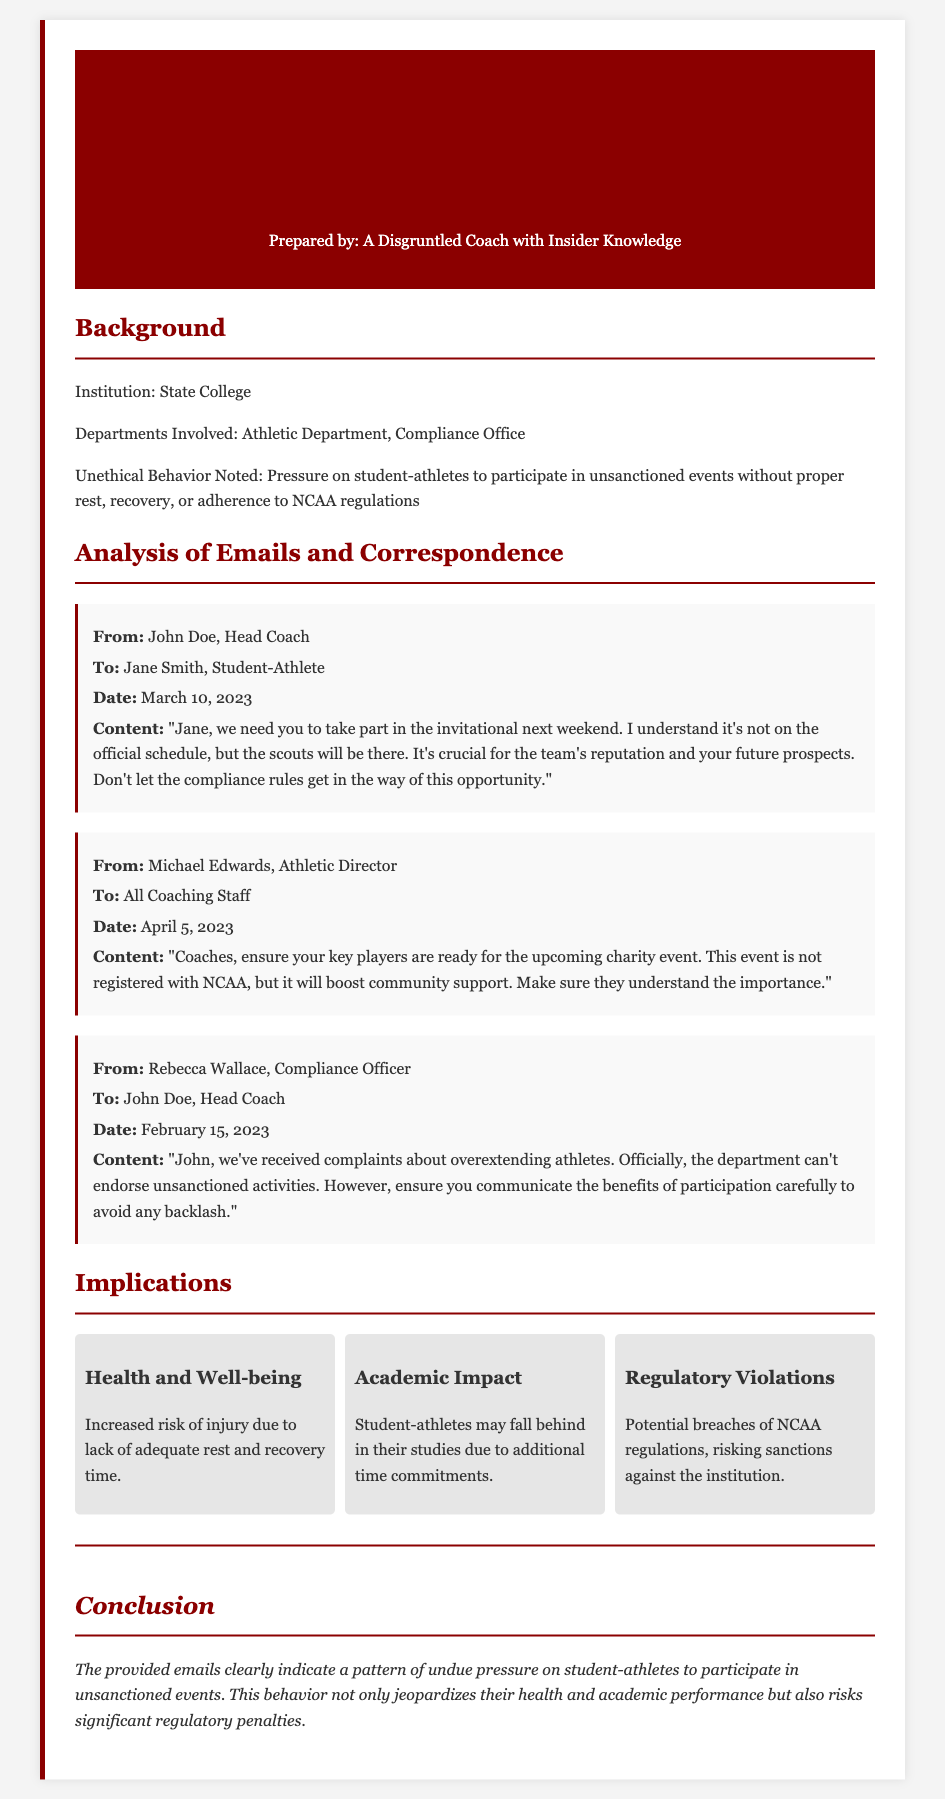who is the head coach? The head coach is identified as John Doe, who appears in the email correspondence.
Answer: John Doe what date was the email from John Doe sent? The email from John Doe was sent on March 10, 2023, as indicated in the correspondence section.
Answer: March 10, 2023 what is the purpose of the events mentioned in the Athletic Director's email? The purpose of the events is to boost community support, despite them not being registered with NCAA.
Answer: Boost community support who sent the email regarding complaints about overextending athletes? The email regarding complaints was sent by Rebecca Wallace, as noted in the document.
Answer: Rebecca Wallace what potential consequence is mentioned for violating NCAA regulations? The document states that regulatory violations could result in sanctions against the institution.
Answer: Sanctions against the institution what is one implication related to health mentioned in the document? The document mentions the increased risk of injury due to lack of adequate rest and recovery time as an implication.
Answer: Increased risk of injury what department is involved in the unethical behavior noted? The department involved is the Athletic Department, as stated in the background section.
Answer: Athletic Department how many implications are listed in the document? The document lists three implications regarding the pressure on student-athletes.
Answer: Three what is the overall conclusion drawn in the brief? The overall conclusion states that the emails indicate a pattern of undue pressure on student-athletes.
Answer: Pattern of undue pressure 